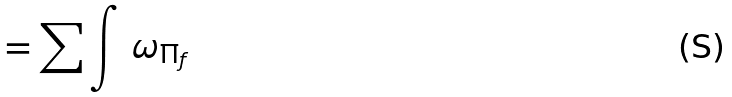Convert formula to latex. <formula><loc_0><loc_0><loc_500><loc_500>= \sum \int \, \omega _ { \Pi _ { f } }</formula> 